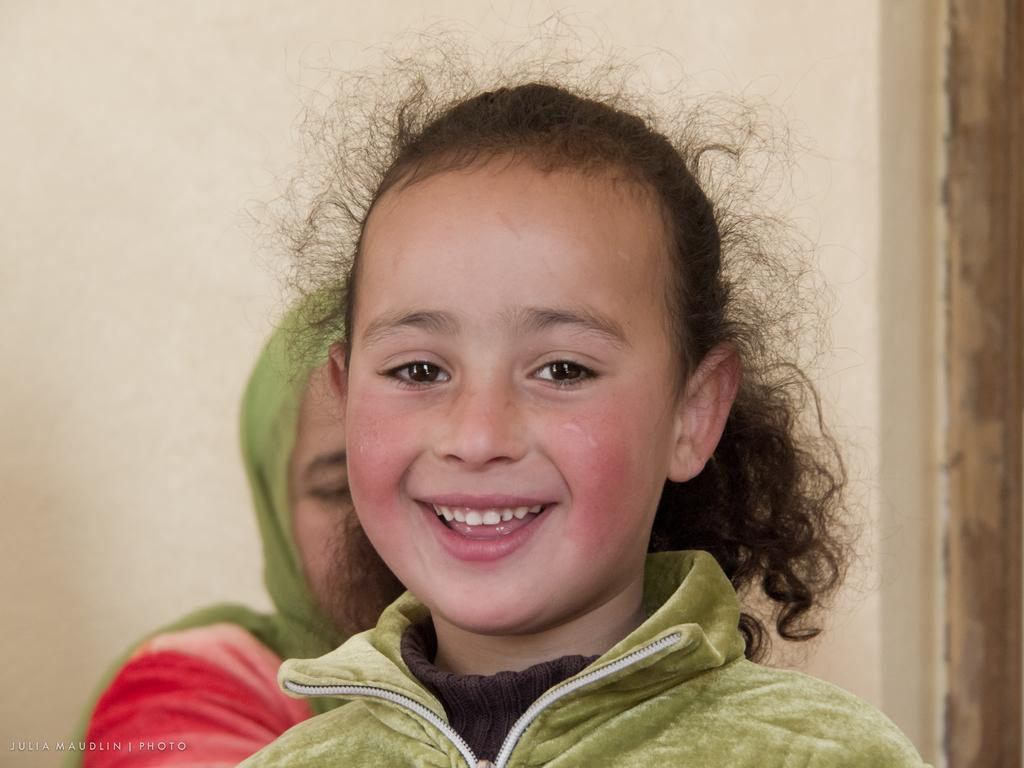Who is the main subject in the image? There is a girl in the image. What is the girl's expression in the image? The girl is smiling in the image. What is the girl wearing on her upper body? The girl is wearing a green color hoodie and a brown color T-shirt. Can you describe the background of the image? There is a wall in the background of the image. Is there anyone else present in the image besides the girl? Yes, there is a woman behind the girl. What type of vest can be seen on the bear in the image? There is no bear or vest present in the image. Can you describe the sink in the image? There is no sink present in the image. 